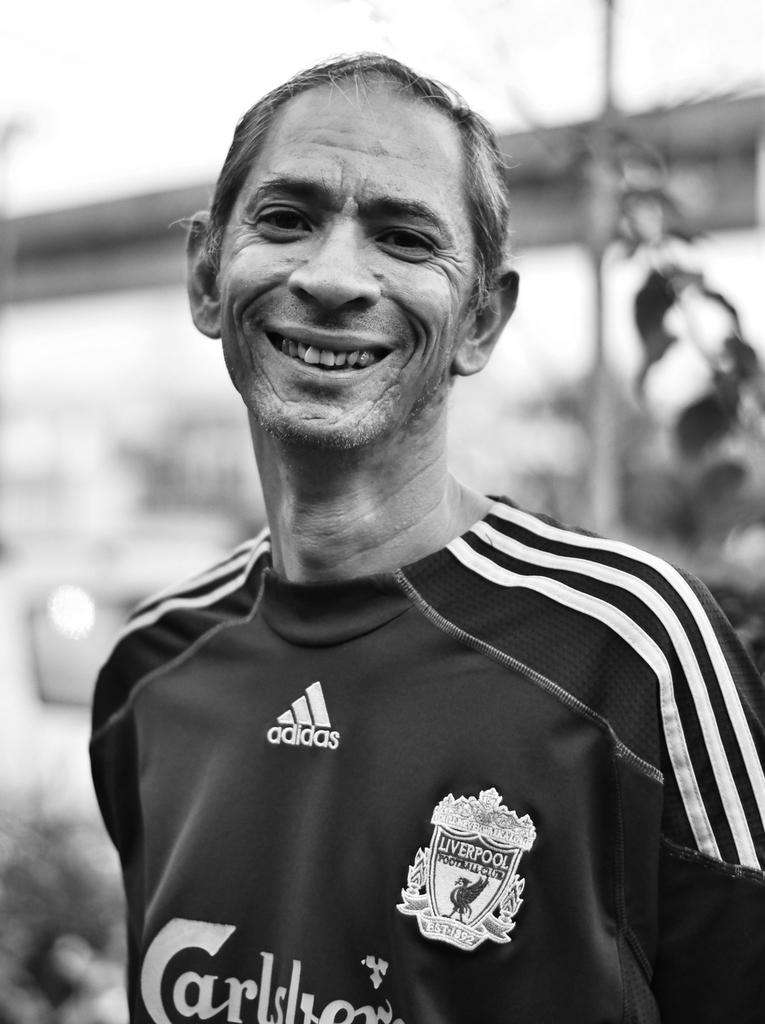<image>
Write a terse but informative summary of the picture. Liverpool Football Club soccer player smiling at camera. 